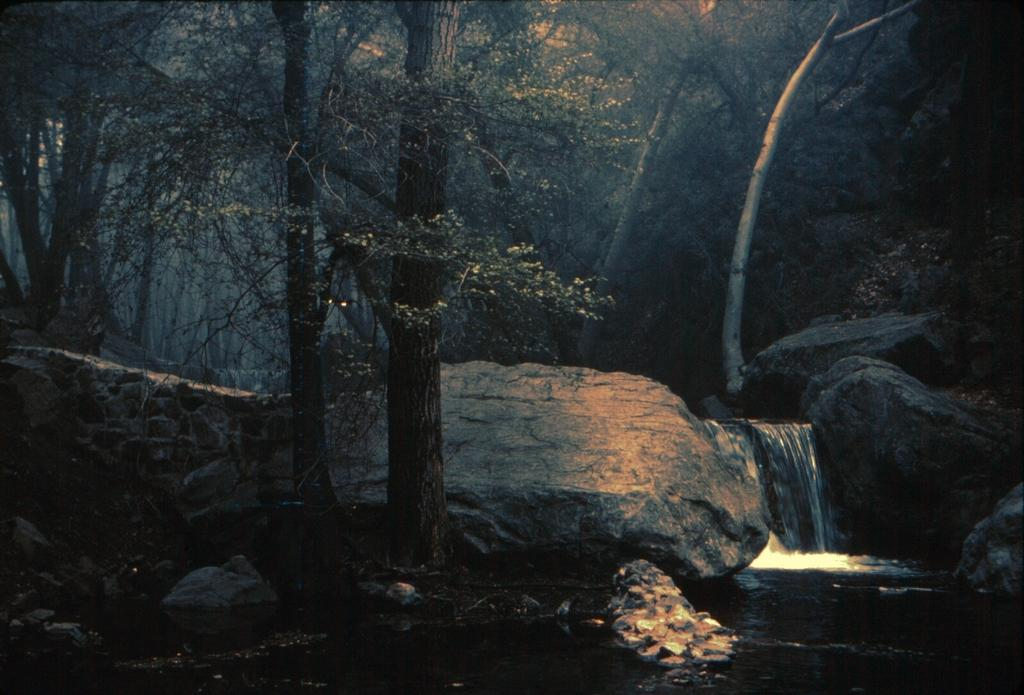What type of vegetation is on the left side of the image? There are trees on the left side of the image. What can be seen on the right side of the image? Water is flowing from stones on the right side of the image. What type of chain can be seen hanging from the trees in the image? There is no chain present in the image; it features trees and flowing water from stones. How does the pencil contribute to the growth of the trees in the image? There is no pencil present in the image, and therefore it cannot contribute to the growth of the trees. 